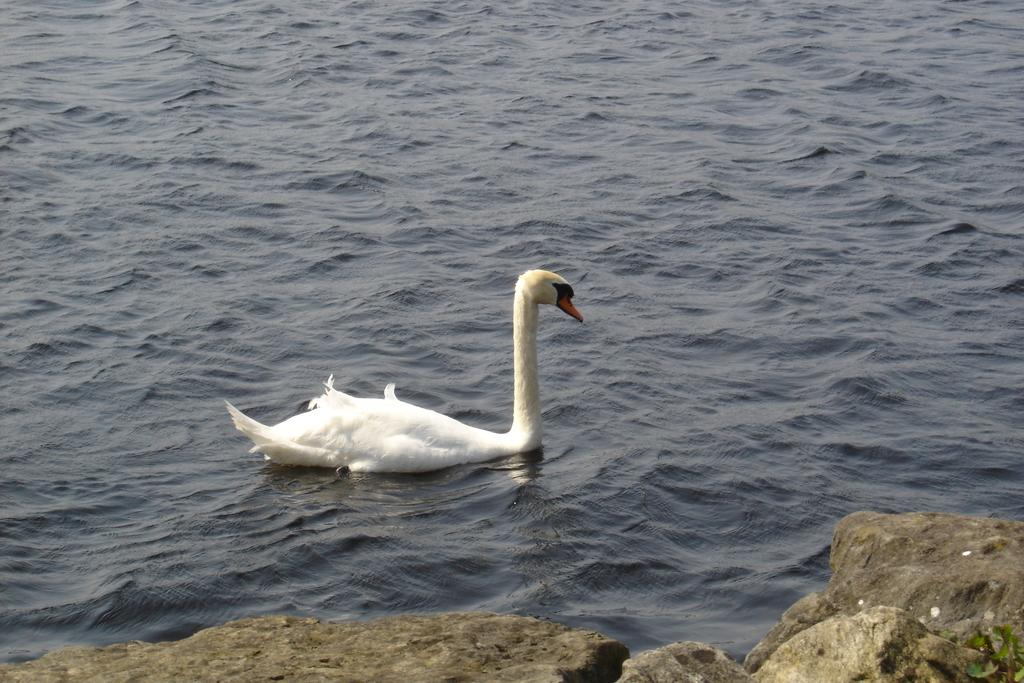What animal is present in the image? There is a swan in the image. What is the swan doing in the image? The swan is swimming in the water. What other objects can be seen in the image? There are rocks in the image. How many legs does the stick have in the image? There is no stick present in the image, so it is not possible to determine how many legs it might have. 